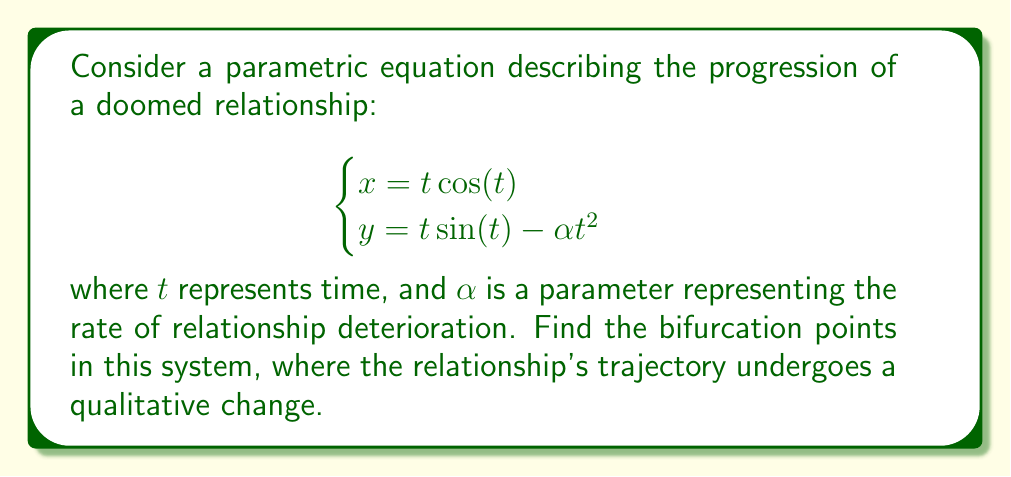Provide a solution to this math problem. To find the bifurcation points, we need to analyze the curvature of the parametric curve. The relationship's trajectory changes qualitatively when the curvature vanishes.

Step 1: Calculate the first derivatives
$$\begin{cases}
x' = \cos(t) - t \sin(t) \\
y' = \sin(t) + t \cos(t) - 2\alpha t
\end{cases}$$

Step 2: Calculate the second derivatives
$$\begin{cases}
x'' = -2\sin(t) - t \cos(t) \\
y'' = 2\cos(t) - t \sin(t) - 2\alpha
\end{cases}$$

Step 3: Calculate the curvature using the formula:
$$\kappa = \frac{x'y'' - y'x''}{(x'^2 + y'^2)^{3/2}}$$

Step 4: Set the numerator of the curvature to zero and simplify:
$$x'y'' - y'x'' = 0$$
$$(\cos(t) - t \sin(t))(2\cos(t) - t \sin(t) - 2\alpha) - (\sin(t) + t \cos(t) - 2\alpha t)(-2\sin(t) - t \cos(t)) = 0$$

Step 5: Simplify the equation:
$$2\alpha t^2 - 2t \sin(t) - 2 = 0$$

Step 6: Solve for $\alpha$:
$$\alpha = \frac{t \sin(t) + 1}{t^2}$$

The bifurcation points occur when this equation is satisfied. As $t$ varies, different values of $\alpha$ will produce qualitative changes in the relationship's trajectory.
Answer: $\alpha = \frac{t \sin(t) + 1}{t^2}$, where $t$ varies. 